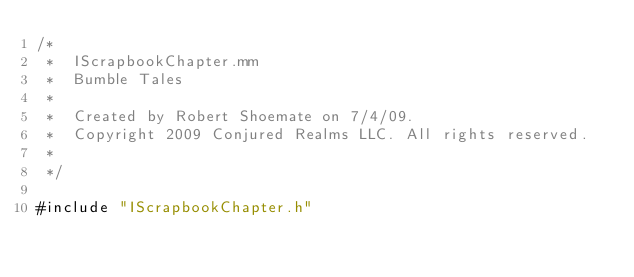Convert code to text. <code><loc_0><loc_0><loc_500><loc_500><_ObjectiveC_>/*
 *  IScrapbookChapter.mm
 *  Bumble Tales
 *
 *  Created by Robert Shoemate on 7/4/09.
 *  Copyright 2009 Conjured Realms LLC. All rights reserved.
 *
 */

#include "IScrapbookChapter.h"

</code> 